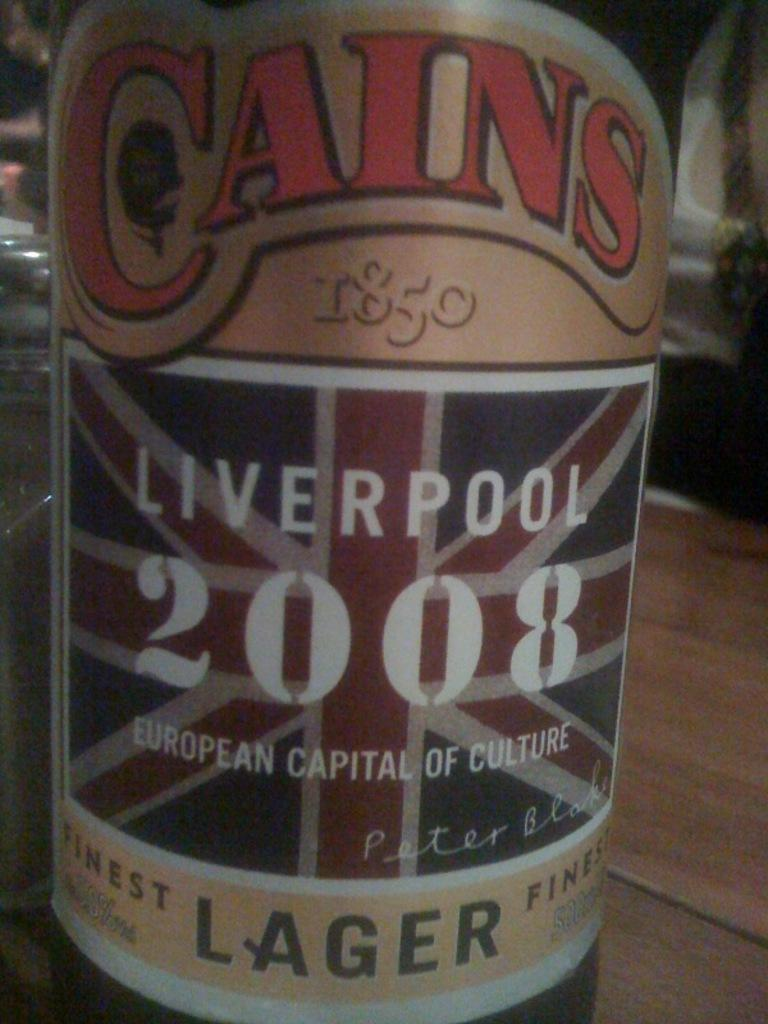<image>
Summarize the visual content of the image. Close up of a beer label that says Liverpool 2008. 